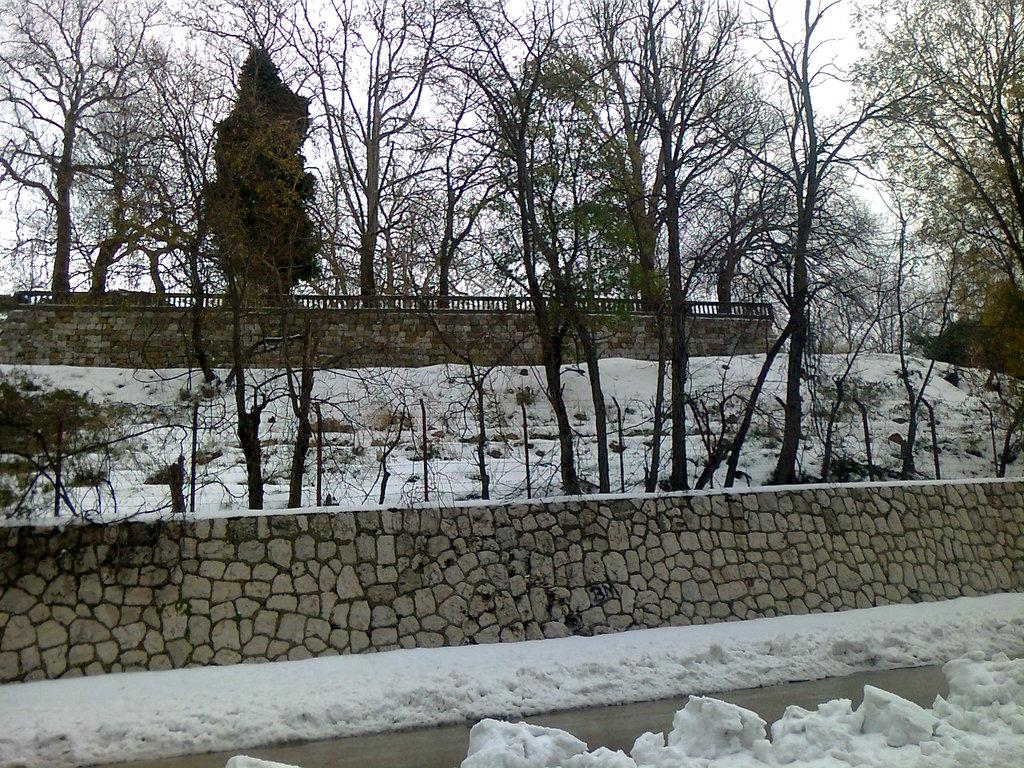What is the primary feature of the landscape in the image? There is snow in the image. What structure can be seen in the image? There is a wall in the image. What type of vegetation is visible in the background of the image? There are many trees in the background of the image. What architectural element is present in the background of the image? There is a railing in the background of the image. What is visible in the sky in the image? The sky is visible in the background of the image. What type of crate can be seen attached to the wing of the airplane in the image? There is no airplane or crate present in the image; it features snow, a wall, trees, a railing, and the sky. How many pancakes are stacked on the plate in the image? There is no plate or pancakes present in the image. 